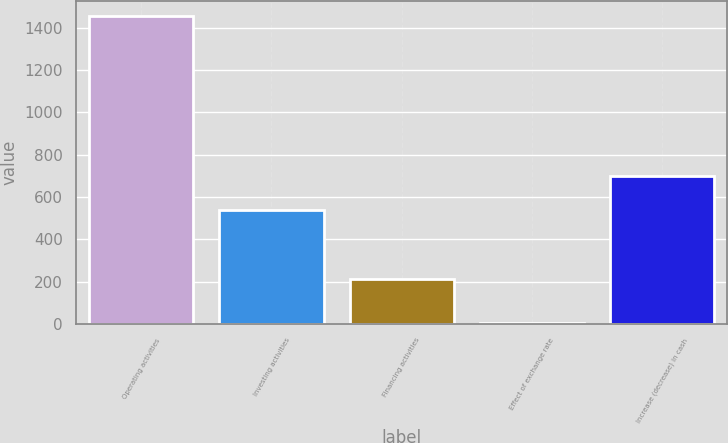Convert chart to OTSL. <chart><loc_0><loc_0><loc_500><loc_500><bar_chart><fcel>Operating activities<fcel>Investing activities<fcel>Financing activities<fcel>Effect of exchange rate<fcel>Increase (decrease) in cash<nl><fcel>1454<fcel>538<fcel>211<fcel>4<fcel>701<nl></chart> 